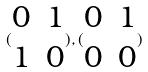<formula> <loc_0><loc_0><loc_500><loc_500>( \begin{matrix} 0 & 1 \\ 1 & 0 \end{matrix} ) , ( \begin{matrix} 0 & 1 \\ 0 & 0 \end{matrix} )</formula> 